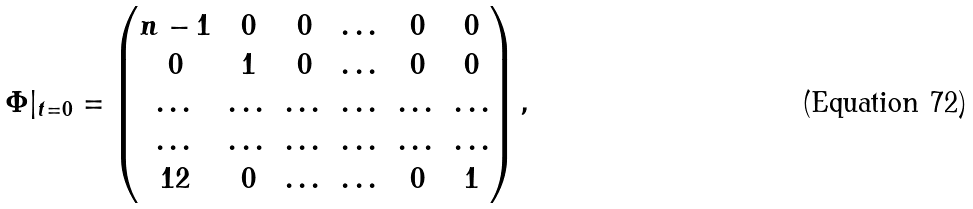<formula> <loc_0><loc_0><loc_500><loc_500>\Phi | _ { t = 0 } = \begin{pmatrix} n - 1 & 0 & 0 & \dots & 0 & 0 \\ 0 & 1 & 0 & \dots & 0 & 0 \\ \dots & \dots & \dots & \dots & \dots & \dots \\ \dots & \dots & \dots & \dots & \dots & \dots \\ 1 2 & 0 & \dots & \dots & 0 & 1 \end{pmatrix} ,</formula> 